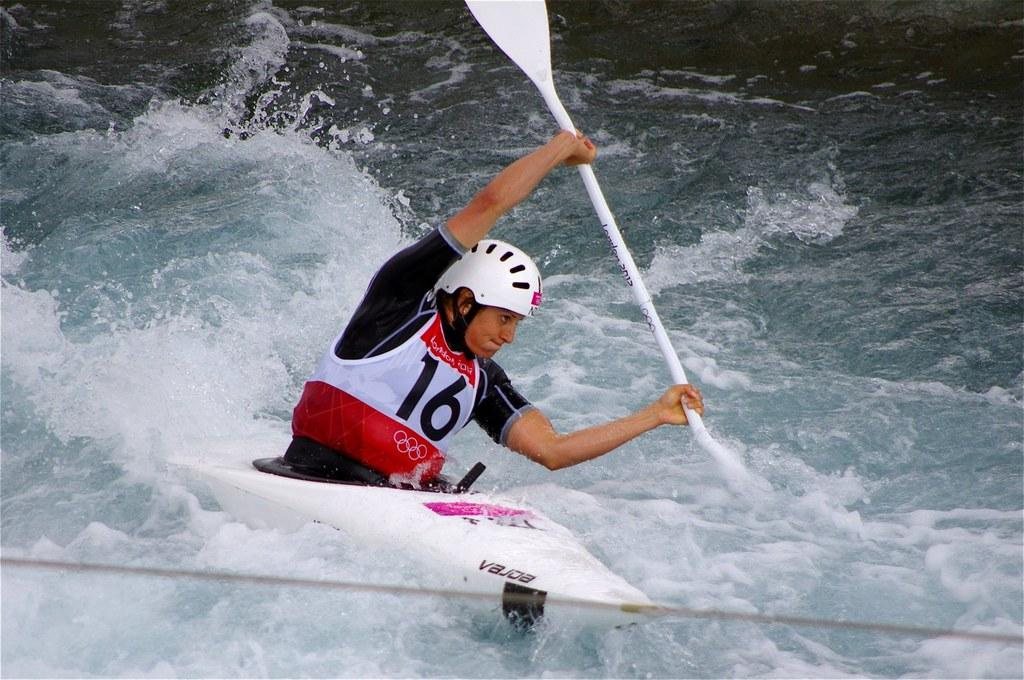What is the main subject of the image? There is a person in the image. What is the person wearing? The person is wearing a black color dress. What activity is the person engaged in? The person is doing river rafting. What safety gear is the person wearing? The person is wearing a helmet. What natural element is visible in the image? There is water visible in the image. What type of meat is being cooked on the ice in the image? There is no meat or ice present in the image; it features a person doing river rafting in water. 